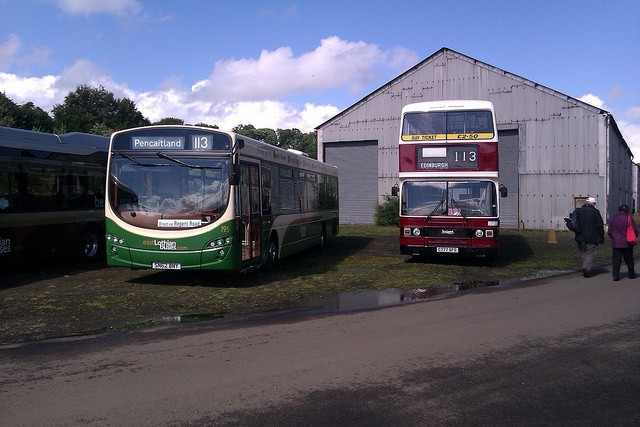Describe the objects in this image and their specific colors. I can see bus in darkgray, black, gray, navy, and darkblue tones, bus in darkgray, gray, black, maroon, and lavender tones, bus in darkgray, black, navy, darkblue, and gray tones, people in darkgray, black, and gray tones, and people in darkgray, black, and purple tones in this image. 